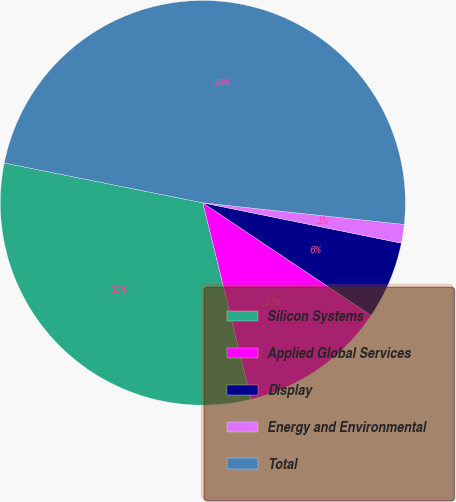<chart> <loc_0><loc_0><loc_500><loc_500><pie_chart><fcel>Silicon Systems<fcel>Applied Global Services<fcel>Display<fcel>Energy and Environmental<fcel>Total<nl><fcel>31.99%<fcel>11.77%<fcel>6.2%<fcel>1.49%<fcel>48.55%<nl></chart> 